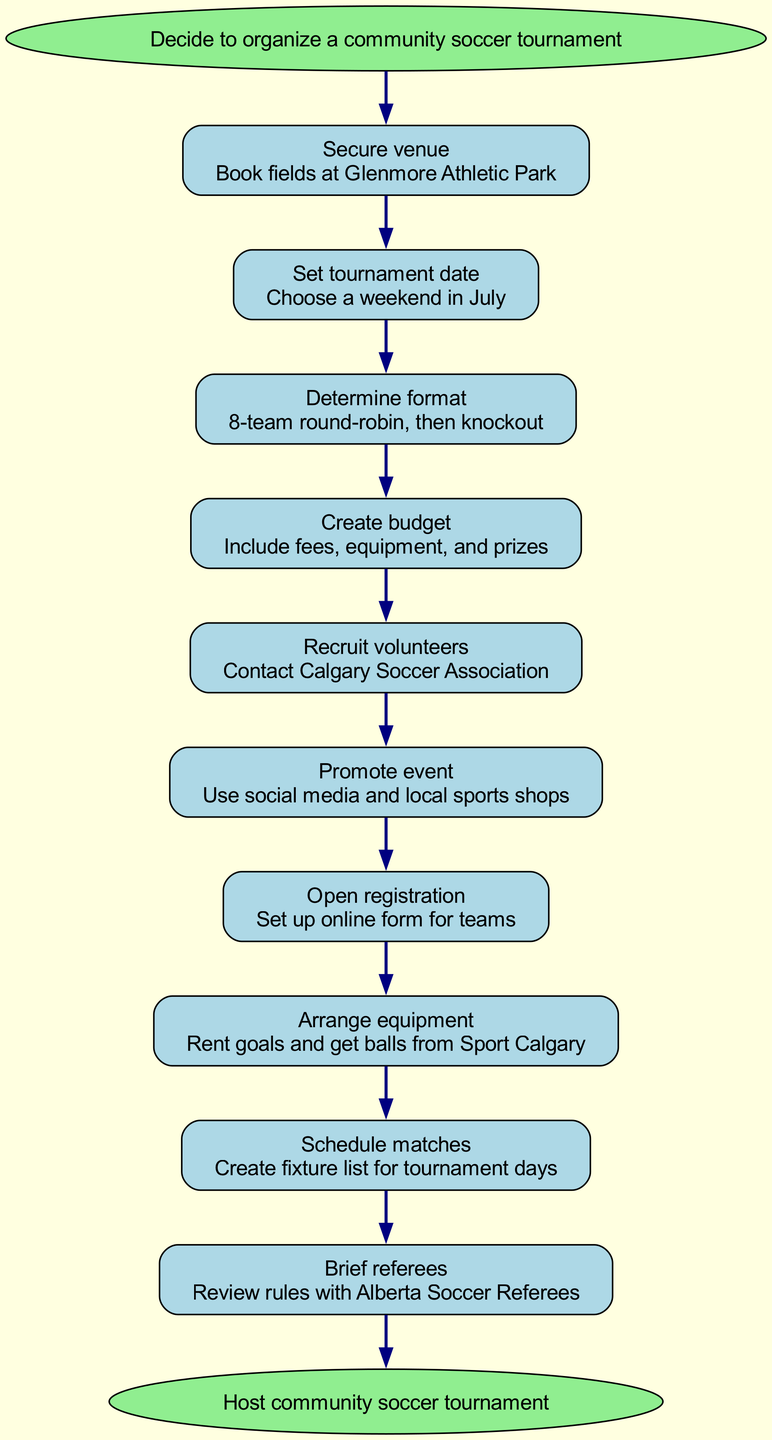What is the first step in organizing the tournament? The diagram starts with the node labeled "Decide to organize a community soccer tournament," which indicates the initial action required for the process.
Answer: Decide to organize a community soccer tournament How many steps are there to complete the organization process? By counting the steps indicated in the diagram, there are a total of ten steps listed before reaching the end.
Answer: Ten What location is specified for securing a venue? The details in the "Secure venue" step mention booking fields at "Glenmore Athletic Park" specifically.
Answer: Glenmore Athletic Park Which step comes after “Create budget”? In the flow from "Create budget," the next step indicated in the diagram is "Recruit volunteers," which follows immediately in the sequence.
Answer: Recruit volunteers What is the last action in the diagram? The end node of the flow chart is labeled "Host community soccer tournament," signifying the final action that concludes the process.
Answer: Host community soccer tournament Which step involves interacting with the Calgary Soccer Association? The node labeled "Recruit volunteers" mentions contacting the Calgary Soccer Association for this task, indicating their role in volunteer recruitment.
Answer: Recruit volunteers Which step comes before “Brief referees”? The step immediately preceding "Brief referees" in the flowchart is "Schedule matches," indicating that matches need to be scheduled before the referees are briefed about them.
Answer: Schedule matches What promotional methods are suggested for the event? The step "Promote event" mentions utilizing "social media and local sports shops," highlighting the suggested promotional avenues for the tournament.
Answer: Social media and local sports shops What format is used for the tournament? The "Determine format" step specifies that the tournament will employ an "8-team round-robin, then knockout" structure for gameplay.
Answer: 8-team round-robin, then knockout 